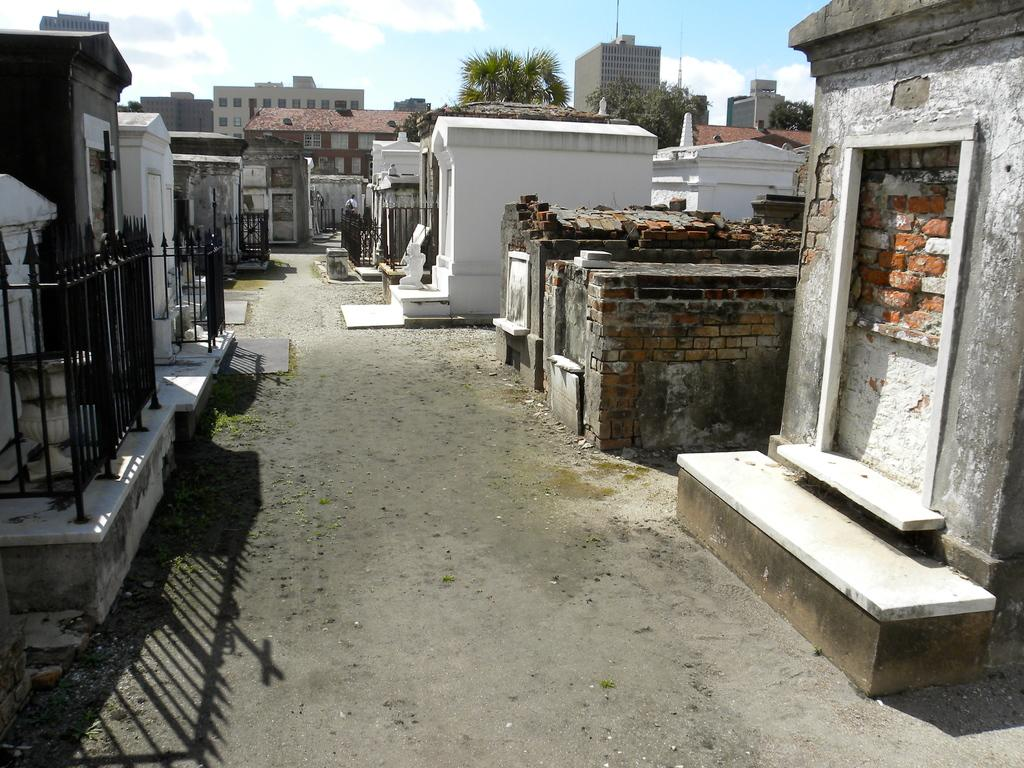What type of structures can be seen in the image? There are houses in the image. What other natural elements are present in the image? There are trees in the image. What type of fencing or barrier can be seen in the image? There are iron grilles in the image. What is visible in the background of the image? The sky is visible in the background of the image. How many pies are being washed in the image? There are no pies or washing activities present in the image. What type of wind can be seen blowing through the image? There is no wind visible in the image, and the term "zephyr" refers to a gentle breeze, which cannot be seen. 